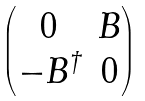<formula> <loc_0><loc_0><loc_500><loc_500>\begin{pmatrix} 0 & B \\ - B ^ { \dagger } & 0 \end{pmatrix}</formula> 